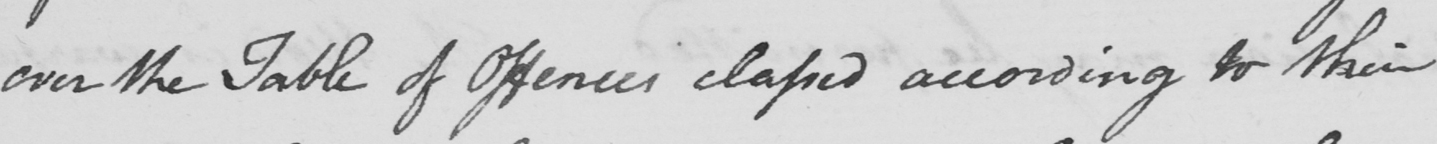Please transcribe the handwritten text in this image. over the table of offences claped according to their 